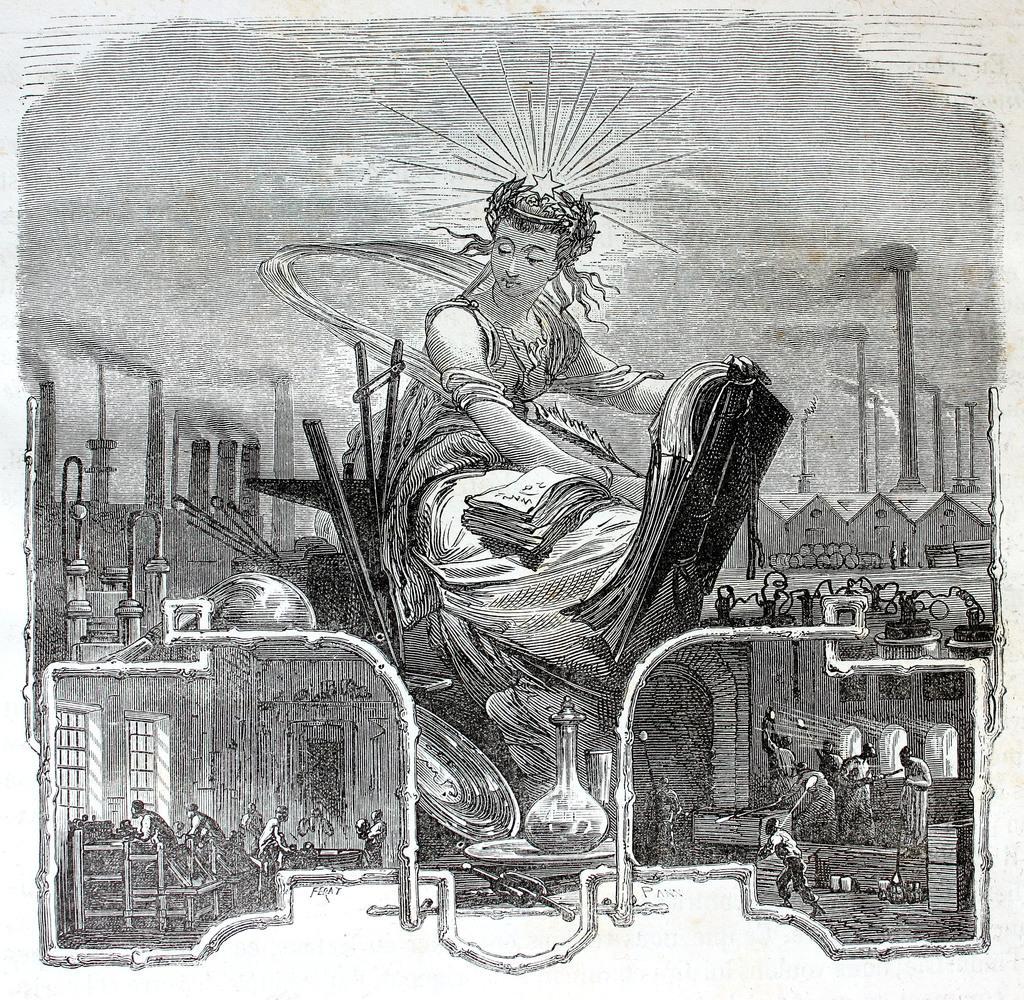Could you give a brief overview of what you see in this image? In this image I can see the person with the dress. To the left there are few more people. In-front of the person there is a table and a vase on the table. In the back there are houses, poles and the sky. 